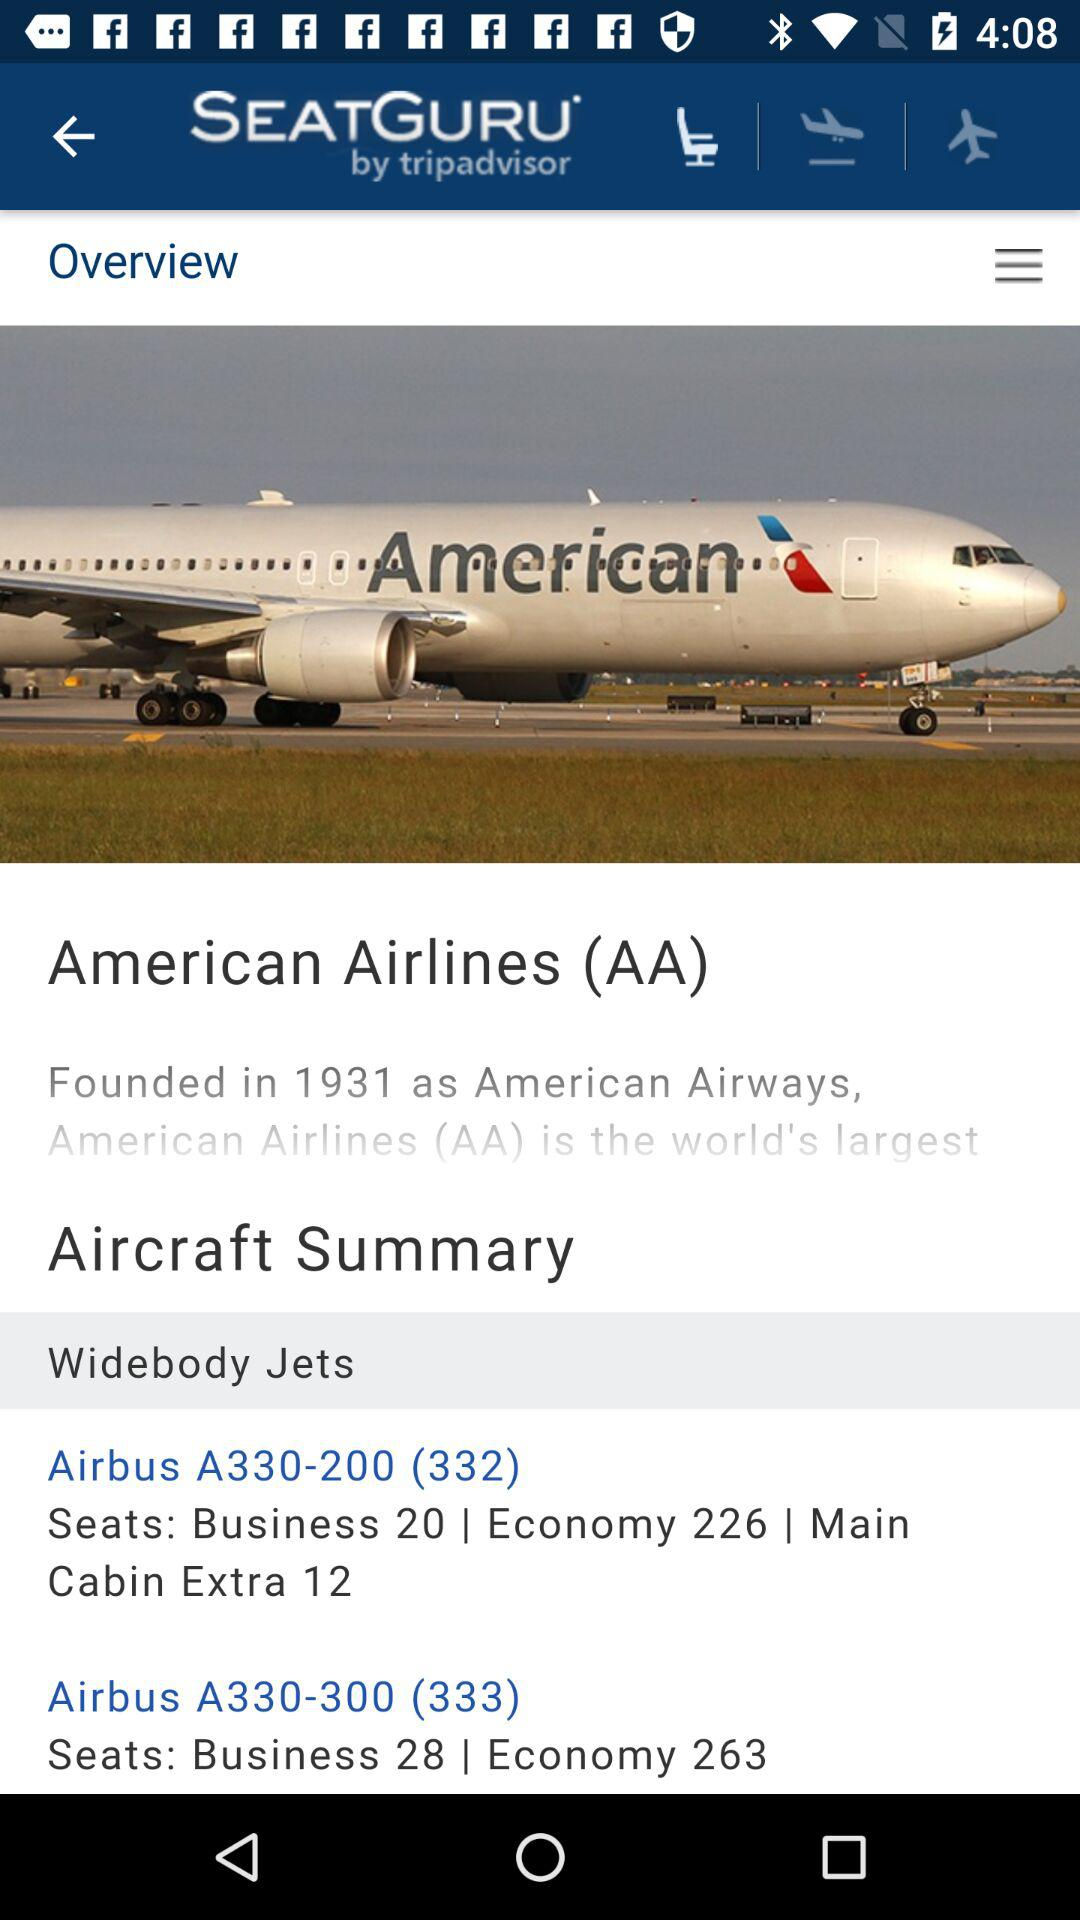What is the number of economy seats in the Airbus A330-200? The number of seats is 226. 